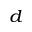Convert formula to latex. <formula><loc_0><loc_0><loc_500><loc_500>_ { d }</formula> 